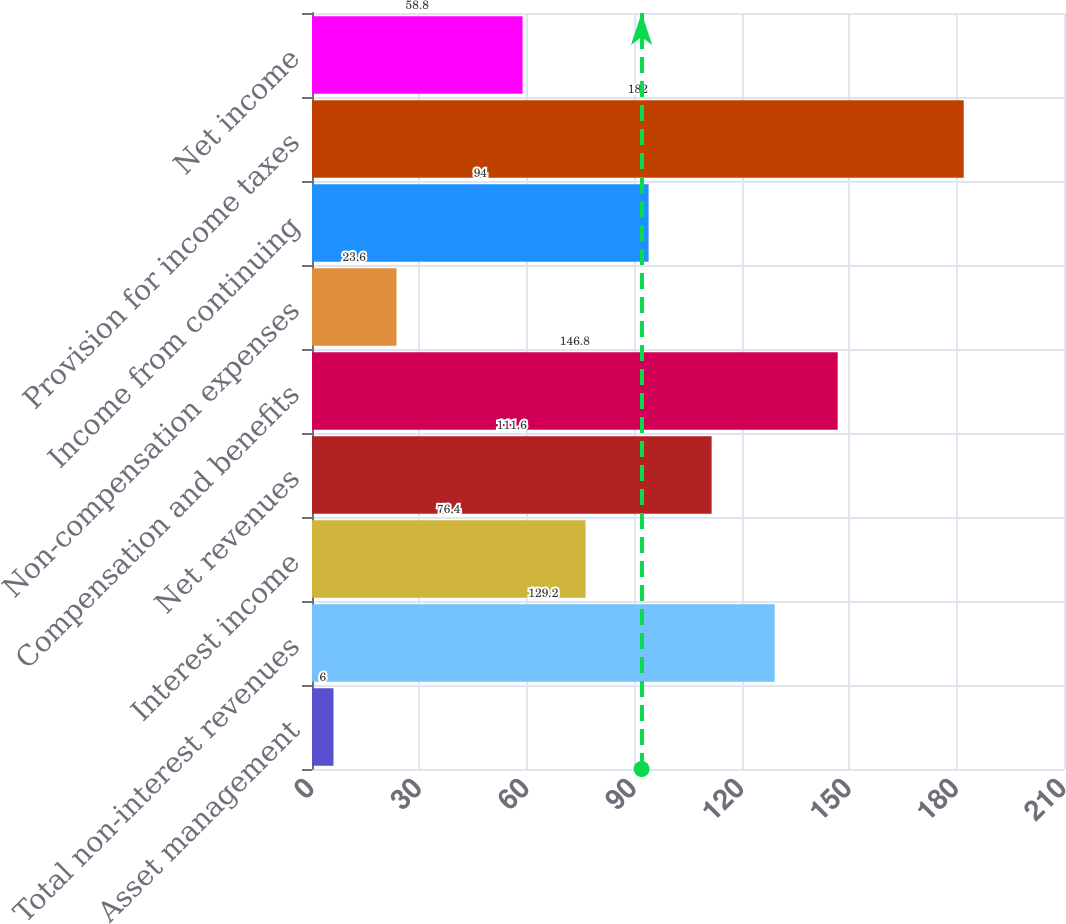Convert chart. <chart><loc_0><loc_0><loc_500><loc_500><bar_chart><fcel>Asset management<fcel>Total non-interest revenues<fcel>Interest income<fcel>Net revenues<fcel>Compensation and benefits<fcel>Non-compensation expenses<fcel>Income from continuing<fcel>Provision for income taxes<fcel>Net income<nl><fcel>6<fcel>129.2<fcel>76.4<fcel>111.6<fcel>146.8<fcel>23.6<fcel>94<fcel>182<fcel>58.8<nl></chart> 